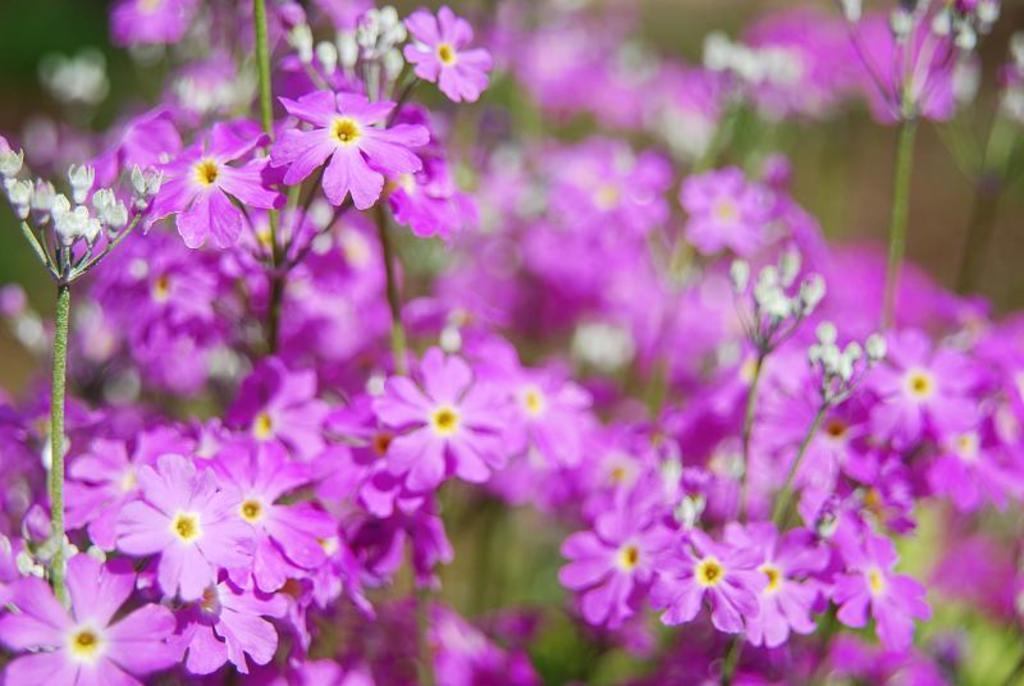Could you give a brief overview of what you see in this image? In this image we can see the flowers, buds and blur background. 